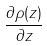Convert formula to latex. <formula><loc_0><loc_0><loc_500><loc_500>\frac { \partial \rho ( z ) } { \partial z }</formula> 